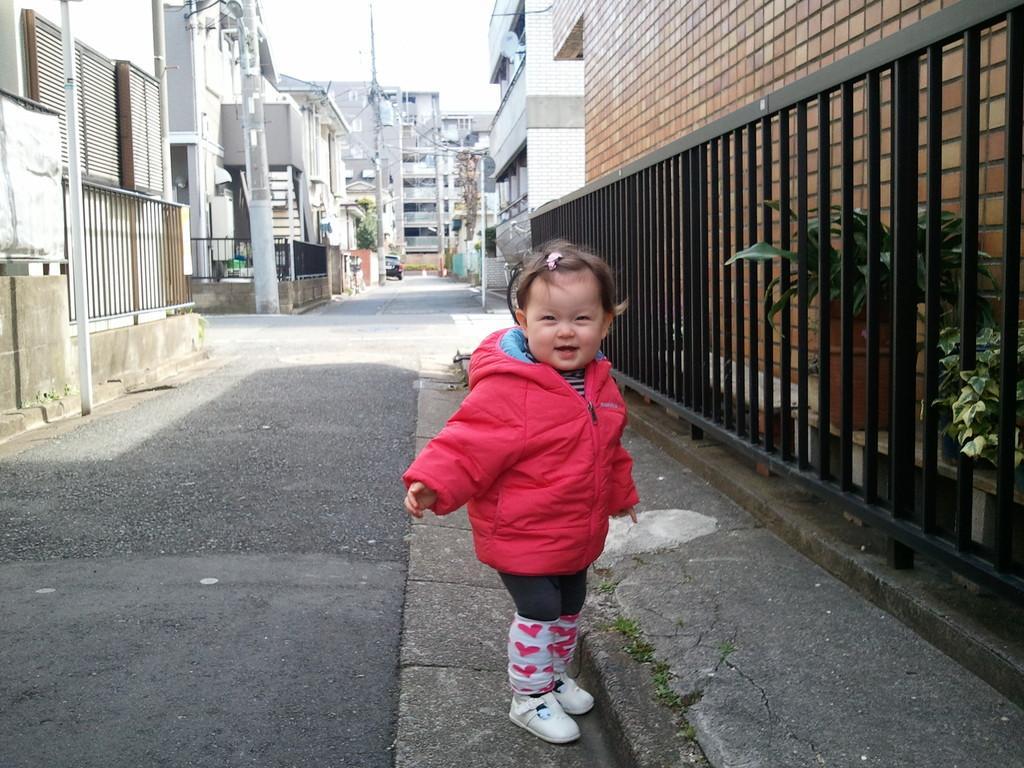Can you describe this image briefly? There is a girl standing and we can see fence,behind the fence we can see house plants and wall. In the background we can see buildings,poles and sky. 